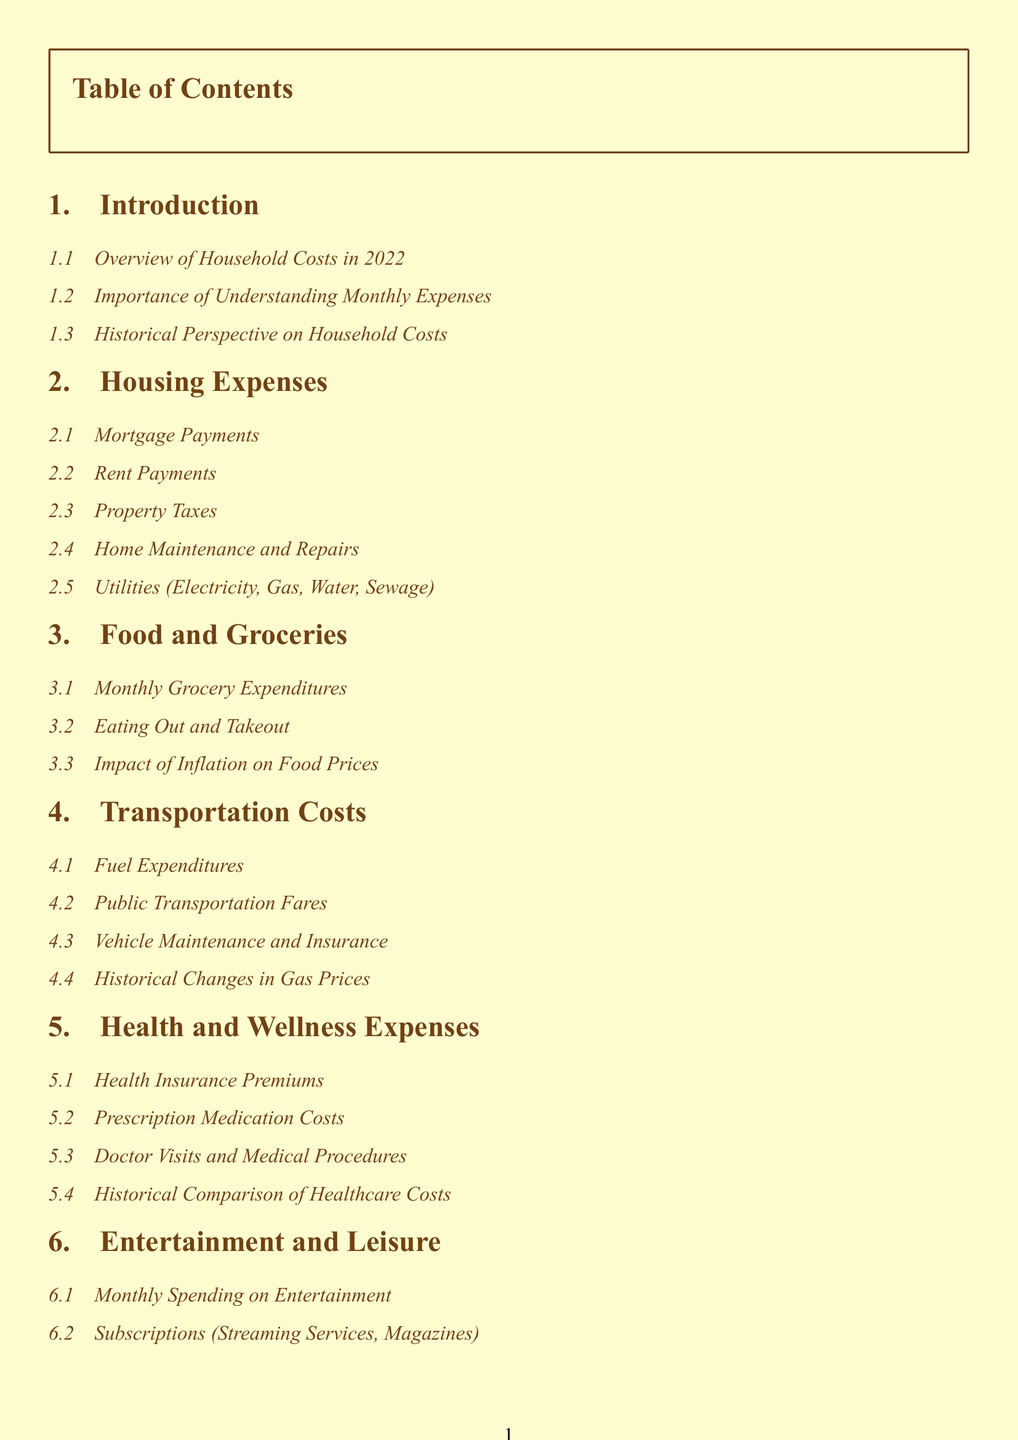What is the primary focus of the document? The primary focus is to provide a detailed breakdown of household costs in 2022.
Answer: Household costs in 2022 What section covers rental expenses? The section related to rental expenses is specifically labeled for housing expenses.
Answer: Housing Expenses How many subsections are there under Health and Wellness Expenses? There are four subsections that discuss various aspects of health and wellness expenses.
Answer: Four What is the impact of inflation on food prices discussed under which section? The impact of inflation on food prices is discussed in the Food and Groceries section, specifically.
Answer: Food and Groceries What type of template is mentioned in the Appendix? The template mentioned in the Appendix is a monthly budget template.
Answer: Monthly budget templates Which section details costs related to leisure activities? The section that details costs related to leisure activities is known as Entertainment and Leisure.
Answer: Entertainment and Leisure What is a key consideration mentioned in the Summary and Conclusion section? A key consideration discussed is the future outlook for budgeting based on changing economic factors.
Answer: Future considerations for budgeting What color theme is used throughout the document? The document utilizes a cream color theme with sepia for the text headings.
Answer: Cream and Sepia How many main sections are included in the document? There are eight main sections included in the document.
Answer: Eight 